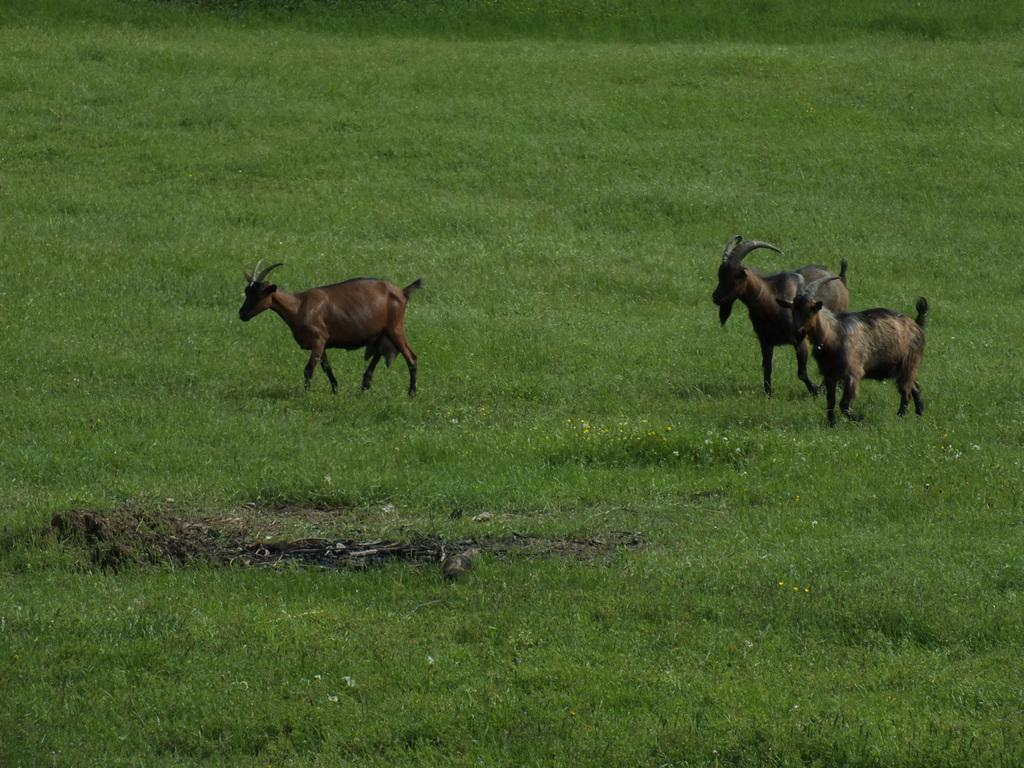How many animals are present in the image? There are three animals in the image. Where are the animals located? The animals are on the grass. What type of tooth can be seen in the image? There is no tooth present in the image; it features three animals on the grass. How many apples are being held by the animals in the image? There is no mention of apples in the image, as it only states that there are three animals on the grass. 